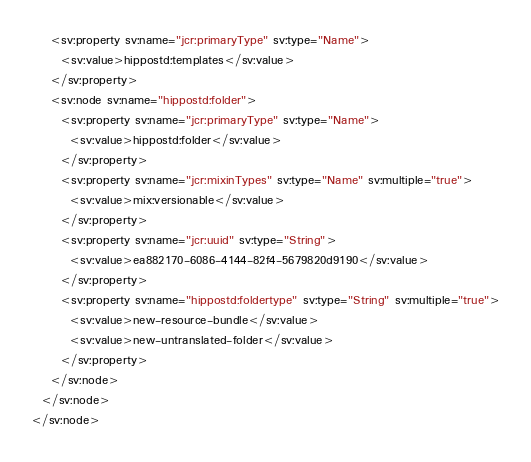<code> <loc_0><loc_0><loc_500><loc_500><_XML_>    <sv:property sv:name="jcr:primaryType" sv:type="Name">
      <sv:value>hippostd:templates</sv:value>
    </sv:property>
    <sv:node sv:name="hippostd:folder">
      <sv:property sv:name="jcr:primaryType" sv:type="Name">
        <sv:value>hippostd:folder</sv:value>
      </sv:property>
      <sv:property sv:name="jcr:mixinTypes" sv:type="Name" sv:multiple="true">
        <sv:value>mix:versionable</sv:value>
      </sv:property>
      <sv:property sv:name="jcr:uuid" sv:type="String">
        <sv:value>ea882170-6086-4144-82f4-5679820d9190</sv:value>
      </sv:property>
      <sv:property sv:name="hippostd:foldertype" sv:type="String" sv:multiple="true">
        <sv:value>new-resource-bundle</sv:value>
        <sv:value>new-untranslated-folder</sv:value>
      </sv:property>
    </sv:node>
  </sv:node>
</sv:node>
</code> 